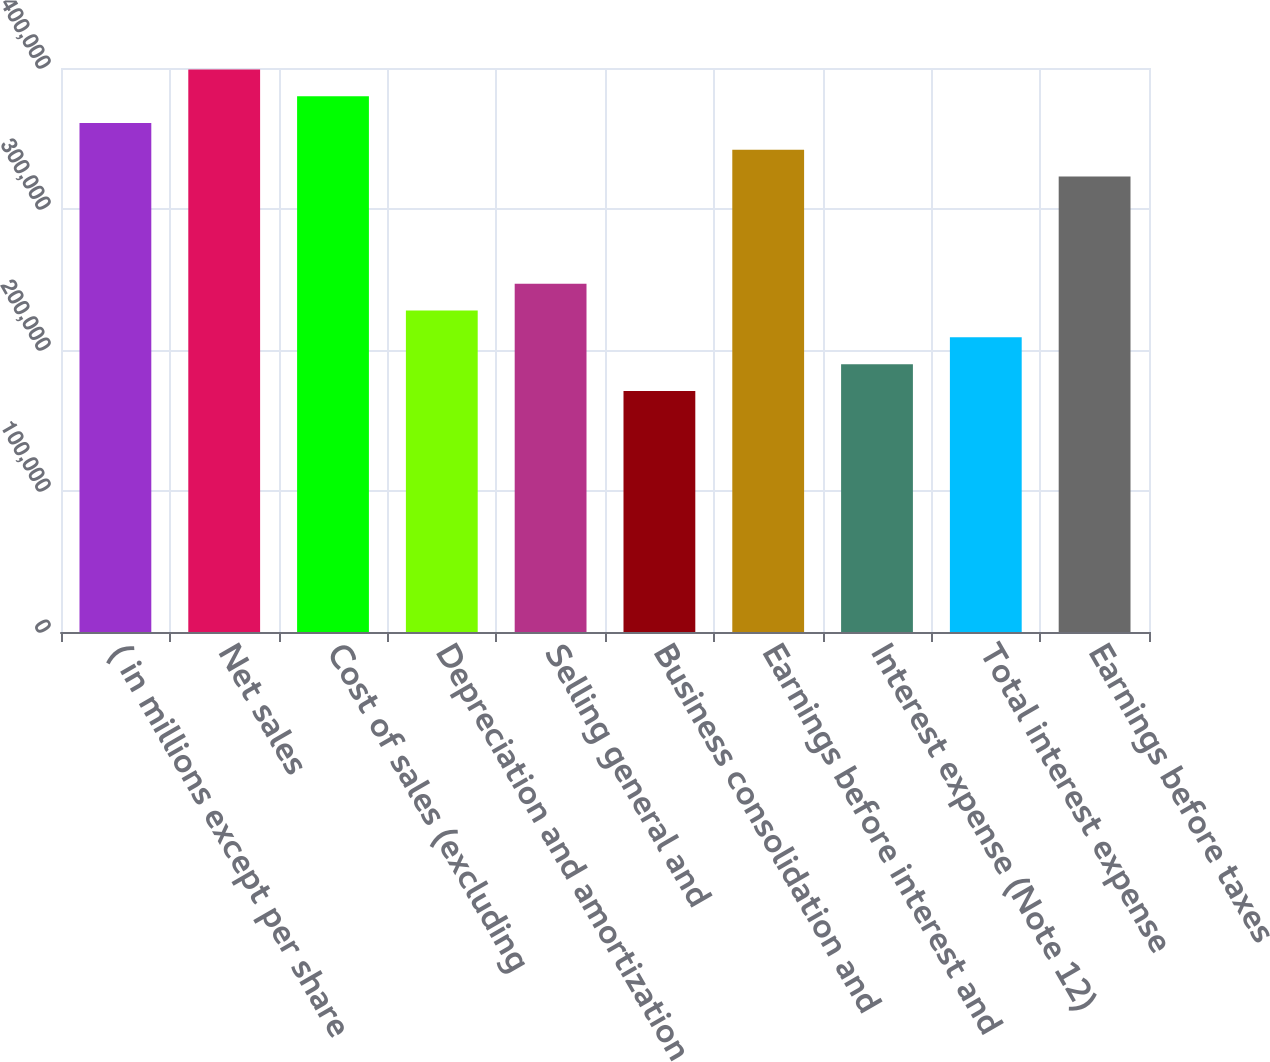<chart> <loc_0><loc_0><loc_500><loc_500><bar_chart><fcel>( in millions except per share<fcel>Net sales<fcel>Cost of sales (excluding<fcel>Depreciation and amortization<fcel>Selling general and<fcel>Business consolidation and<fcel>Earnings before interest and<fcel>Interest expense (Note 12)<fcel>Total interest expense<fcel>Earnings before taxes<nl><fcel>360958<fcel>398954<fcel>379956<fcel>227974<fcel>246971<fcel>170980<fcel>341960<fcel>189978<fcel>208976<fcel>322963<nl></chart> 